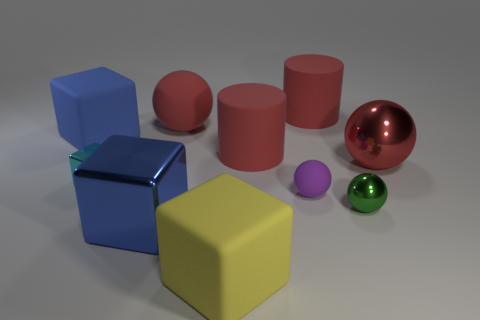Subtract all blue cubes. How many were subtracted if there are1blue cubes left? 1 Subtract all yellow matte cubes. How many cubes are left? 3 Subtract all gray cubes. How many red balls are left? 2 Subtract 2 spheres. How many spheres are left? 2 Subtract all blue cubes. How many cubes are left? 2 Subtract all cylinders. How many objects are left? 8 Add 7 big metallic blocks. How many big metallic blocks exist? 8 Subtract 1 yellow blocks. How many objects are left? 9 Subtract all purple spheres. Subtract all cyan blocks. How many spheres are left? 3 Subtract all large blue metal cubes. Subtract all large rubber things. How many objects are left? 4 